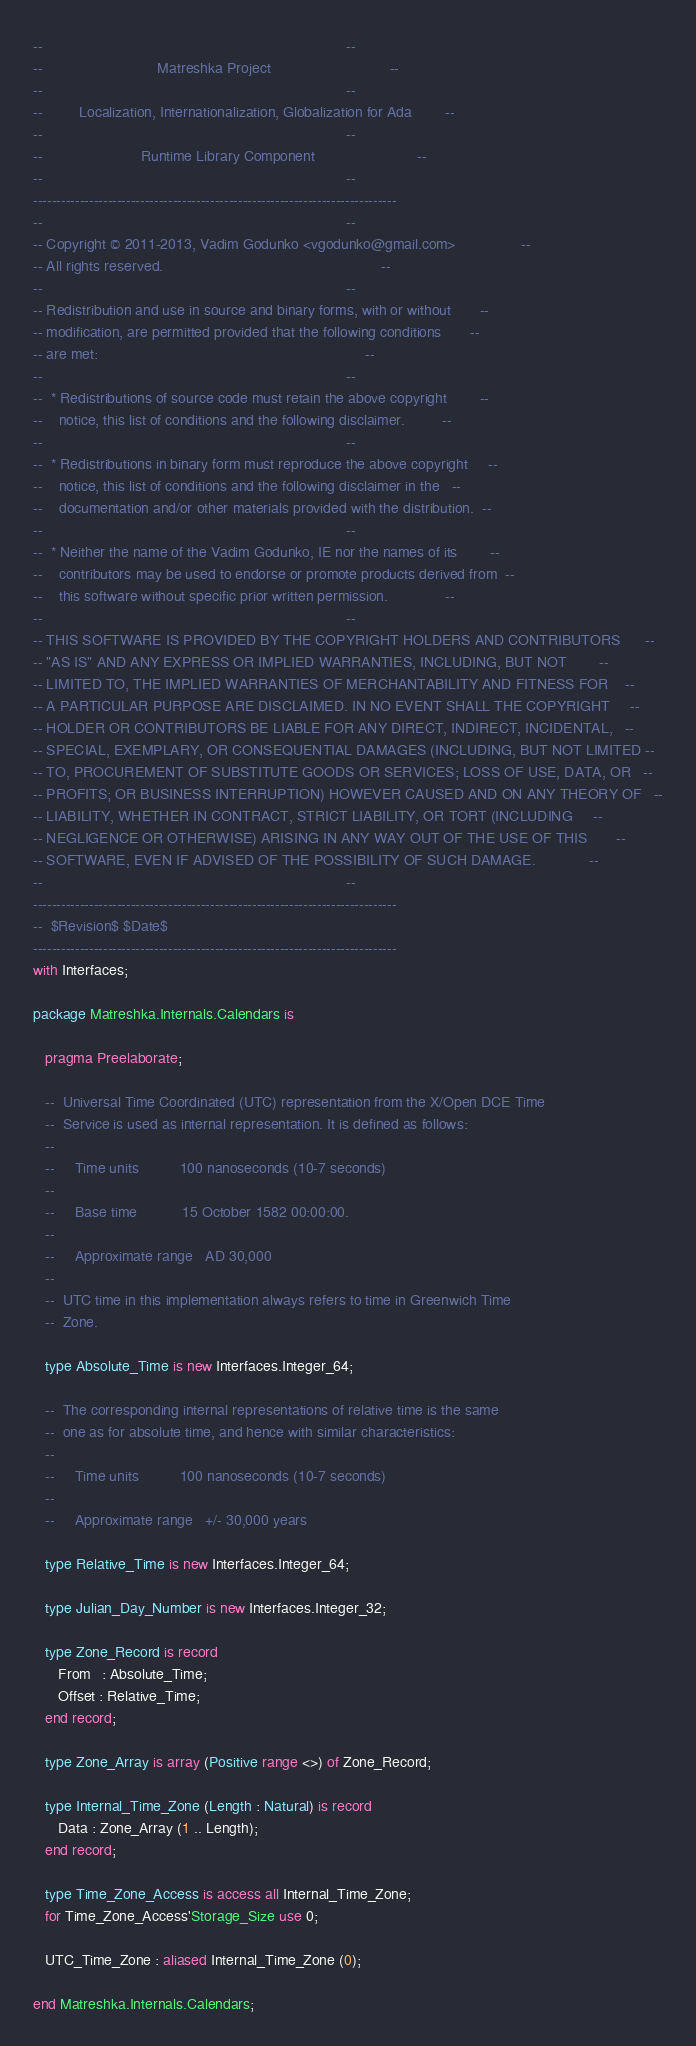<code> <loc_0><loc_0><loc_500><loc_500><_Ada_>--                                                                          --
--                            Matreshka Project                             --
--                                                                          --
--         Localization, Internationalization, Globalization for Ada        --
--                                                                          --
--                        Runtime Library Component                         --
--                                                                          --
------------------------------------------------------------------------------
--                                                                          --
-- Copyright © 2011-2013, Vadim Godunko <vgodunko@gmail.com>                --
-- All rights reserved.                                                     --
--                                                                          --
-- Redistribution and use in source and binary forms, with or without       --
-- modification, are permitted provided that the following conditions       --
-- are met:                                                                 --
--                                                                          --
--  * Redistributions of source code must retain the above copyright        --
--    notice, this list of conditions and the following disclaimer.         --
--                                                                          --
--  * Redistributions in binary form must reproduce the above copyright     --
--    notice, this list of conditions and the following disclaimer in the   --
--    documentation and/or other materials provided with the distribution.  --
--                                                                          --
--  * Neither the name of the Vadim Godunko, IE nor the names of its        --
--    contributors may be used to endorse or promote products derived from  --
--    this software without specific prior written permission.              --
--                                                                          --
-- THIS SOFTWARE IS PROVIDED BY THE COPYRIGHT HOLDERS AND CONTRIBUTORS      --
-- "AS IS" AND ANY EXPRESS OR IMPLIED WARRANTIES, INCLUDING, BUT NOT        --
-- LIMITED TO, THE IMPLIED WARRANTIES OF MERCHANTABILITY AND FITNESS FOR    --
-- A PARTICULAR PURPOSE ARE DISCLAIMED. IN NO EVENT SHALL THE COPYRIGHT     --
-- HOLDER OR CONTRIBUTORS BE LIABLE FOR ANY DIRECT, INDIRECT, INCIDENTAL,   --
-- SPECIAL, EXEMPLARY, OR CONSEQUENTIAL DAMAGES (INCLUDING, BUT NOT LIMITED --
-- TO, PROCUREMENT OF SUBSTITUTE GOODS OR SERVICES; LOSS OF USE, DATA, OR   --
-- PROFITS; OR BUSINESS INTERRUPTION) HOWEVER CAUSED AND ON ANY THEORY OF   --
-- LIABILITY, WHETHER IN CONTRACT, STRICT LIABILITY, OR TORT (INCLUDING     --
-- NEGLIGENCE OR OTHERWISE) ARISING IN ANY WAY OUT OF THE USE OF THIS       --
-- SOFTWARE, EVEN IF ADVISED OF THE POSSIBILITY OF SUCH DAMAGE.             --
--                                                                          --
------------------------------------------------------------------------------
--  $Revision$ $Date$
------------------------------------------------------------------------------
with Interfaces;

package Matreshka.Internals.Calendars is

   pragma Preelaborate;

   --  Universal Time Coordinated (UTC) representation from the X/Open DCE Time
   --  Service is used as internal representation. It is defined as follows:
   --
   --     Time units          100 nanoseconds (10-7 seconds)
   --
   --     Base time           15 October 1582 00:00:00.
   --
   --     Approximate range   AD 30,000
   --
   --  UTC time in this implementation always refers to time in Greenwich Time
   --  Zone.

   type Absolute_Time is new Interfaces.Integer_64;

   --  The corresponding internal representations of relative time is the same
   --  one as for absolute time, and hence with similar characteristics:
   --
   --     Time units          100 nanoseconds (10-7 seconds)
   --
   --     Approximate range   +/- 30,000 years

   type Relative_Time is new Interfaces.Integer_64;

   type Julian_Day_Number is new Interfaces.Integer_32;

   type Zone_Record is record
      From   : Absolute_Time;
      Offset : Relative_Time;
   end record;

   type Zone_Array is array (Positive range <>) of Zone_Record;

   type Internal_Time_Zone (Length : Natural) is record
      Data : Zone_Array (1 .. Length);
   end record;

   type Time_Zone_Access is access all Internal_Time_Zone;
   for Time_Zone_Access'Storage_Size use 0;

   UTC_Time_Zone : aliased Internal_Time_Zone (0);

end Matreshka.Internals.Calendars;
</code> 